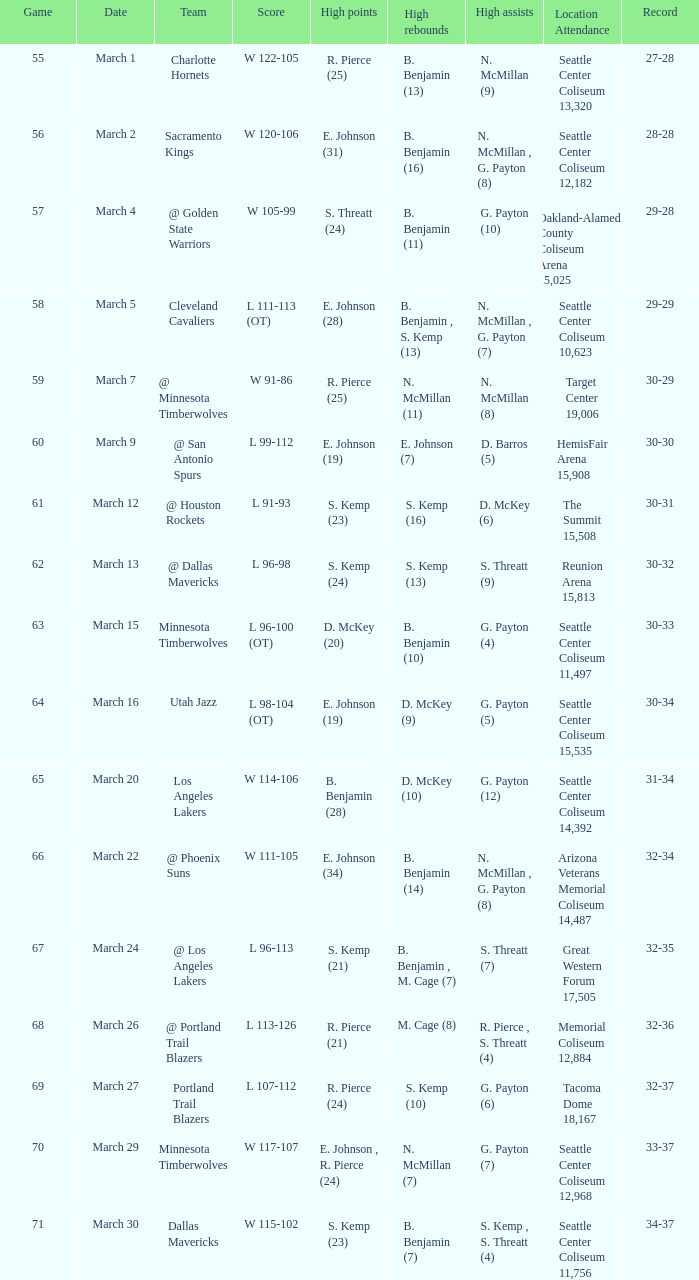What game took place on march 2nd? 56.0. 